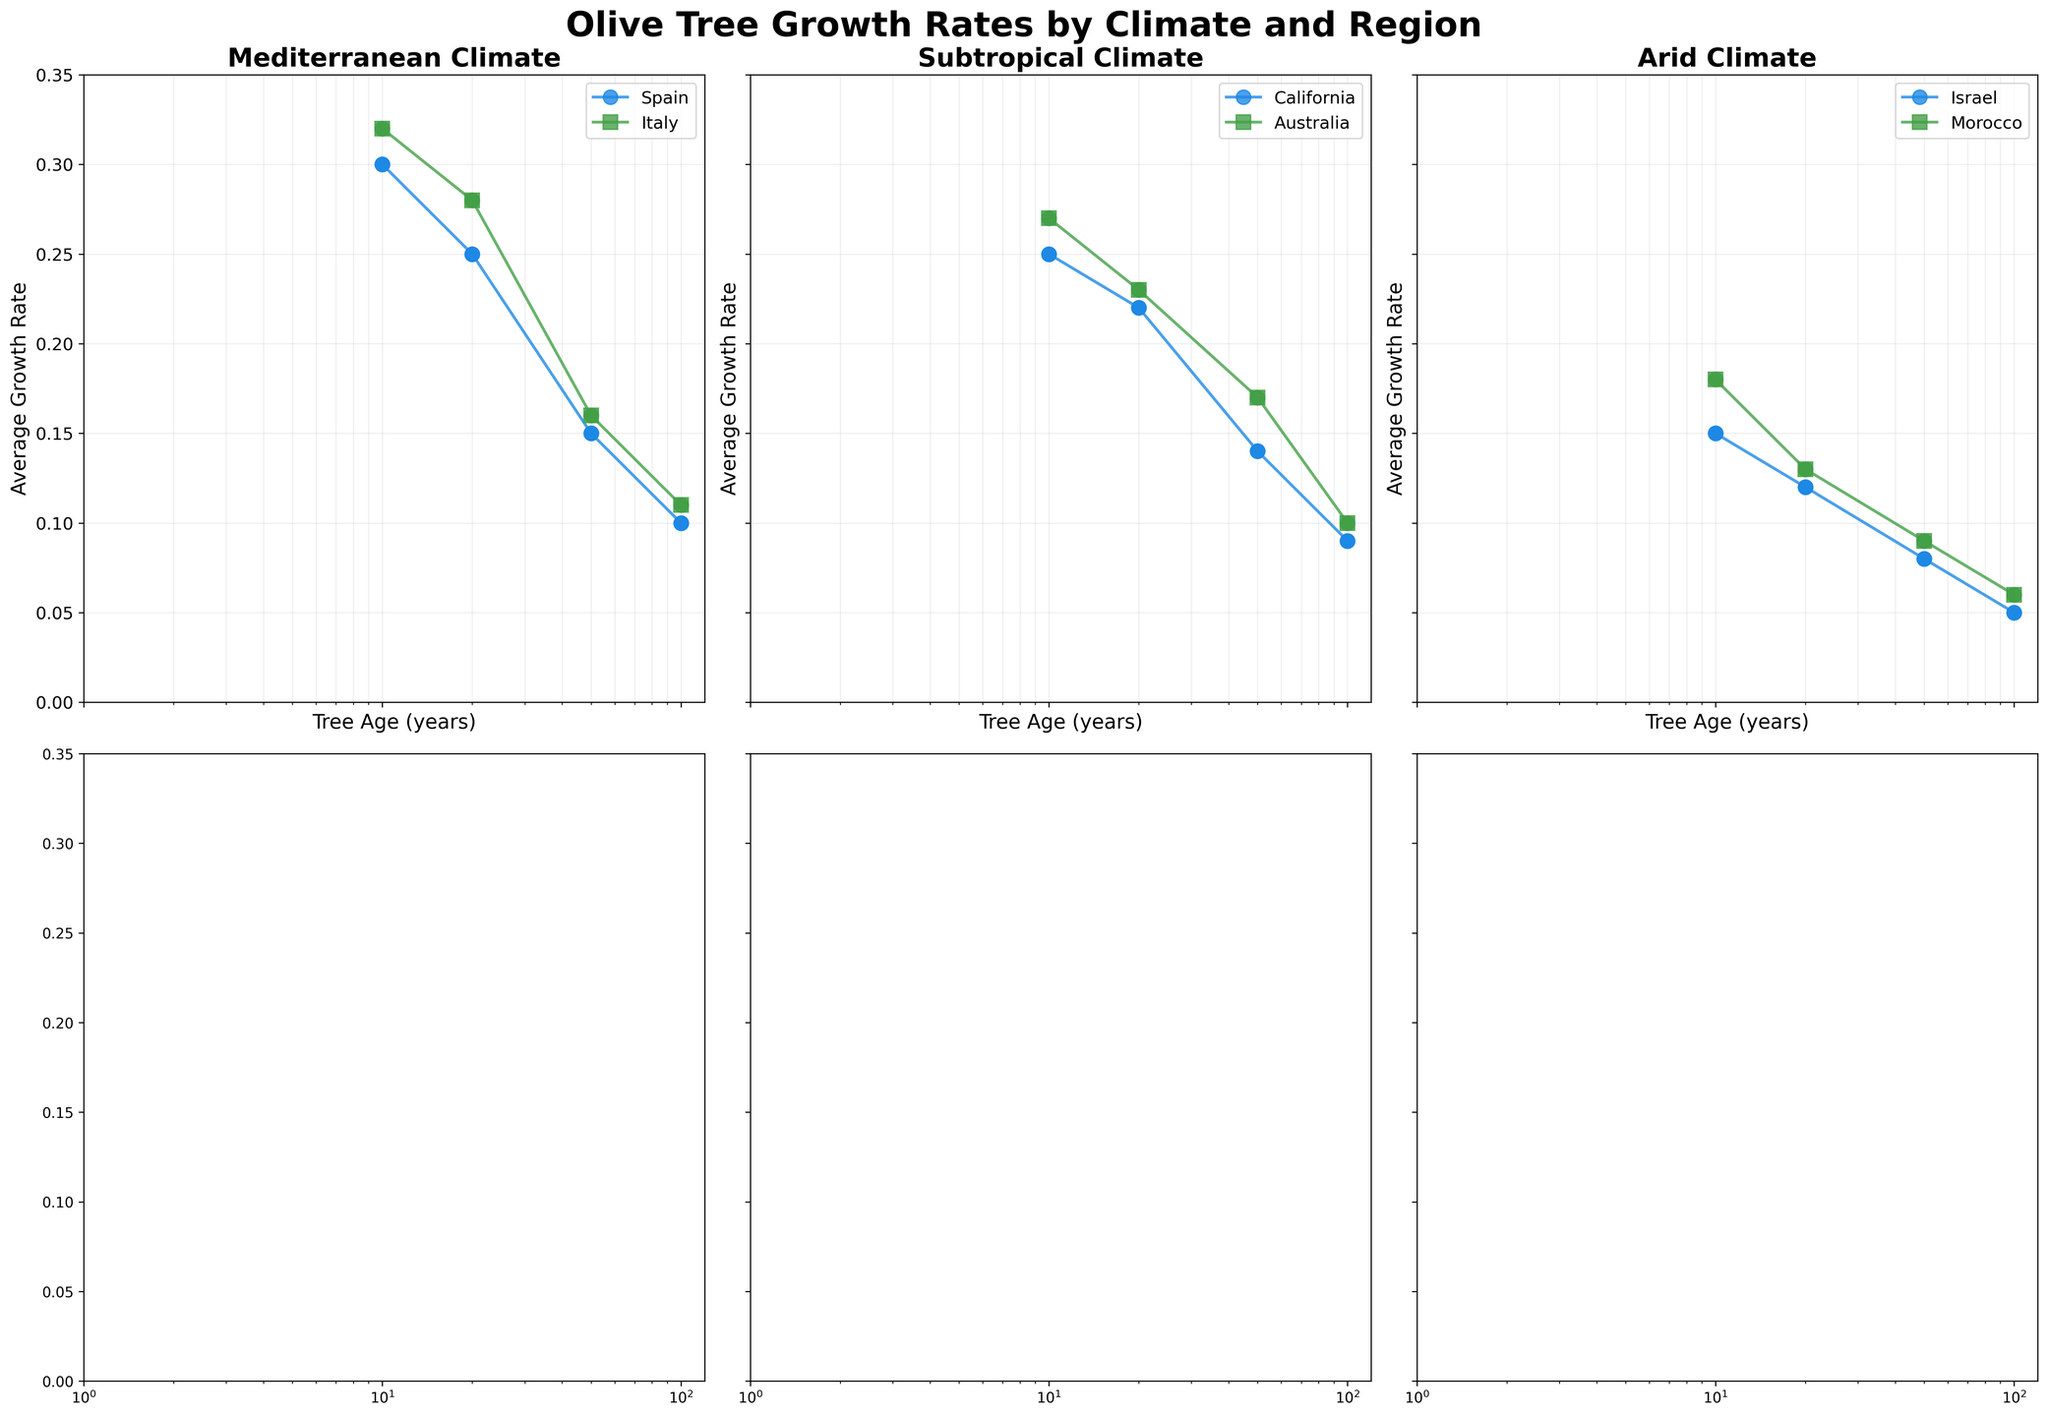Which climate has the highest average growth rate for olive trees aged 0-10 years? Look at each subplot, find the region with the highest average growth rate in each climate category, and then identify the highest amongst those. Mediterranean (Italy) has the highest rate at 0.32.
Answer: Mediterranean In the Mediterranean climate, what is the difference in average growth rate between olive trees aged 0-10 years and those aged 50-100 years in Italy? Refer to the Mediterranean subplot for Italy, and subtract the average growth rate of the 50-100 years age range (0.11) from that of the 0-10 years age range (0.32). 0.32 - 0.11 = 0.21
Answer: 0.21 Which region in the arid climate has a lower average growth rate for olive trees aged 10-20 years, Israel or Morocco? Refer to the arid subplot, and compare the growth rate for 10-20 years between Israel (0.12) and Morocco (0.13). Israel's is lower.
Answer: Israel What is the trend of average growth rates in California as olive trees age? Look at the subtropical subplot for California, and observe the pattern of average growth rates as age increases, noting if it rises, falls, or stays constant. It decreases over time.
Answer: Decreasing Which climate shows the least variability in average growth rates over different olive tree age ranges? Compare the range of average growth rates across different age ranges for each climate. The arid climate shows the least variability, with rates ranging from 0.05 to 0.18.
Answer: Arid How does the average growth rate for 20-50 year-old olive trees in Australia compare to that in Spain? Look at the Mediterranean subplot for Spain and the subtropical subplot for Australia and compare the values for the 20-50 year age range. Spain has 0.15 and Australia has 0.17.
Answer: Australia What is the average growth rate difference for olive trees aged 0-10 years between the Mediterranean and Arid climates? Find the average growth rates for the 0-10 year age range in the Mediterranean (average rates of regions) and Arid climates, then subtract the Arid rate from the Mediterranean rate. Mediterranean ranges are Spain 0.3, Italy 0.32. Arid ranges are Israel 0.15, Morocco 0.18. Average Mediterranean = (0.3+0.32)/2 = 0.31. Average Arid = (0.15+0.18)/2 = 0.165. 0.31 - 0.165 = 0.145
Answer: 0.145 